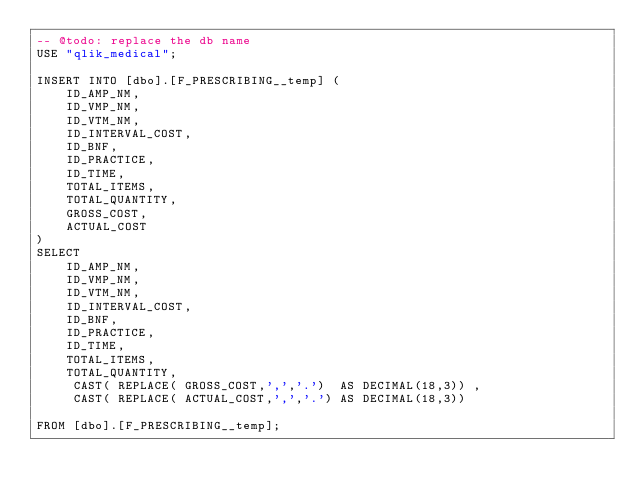<code> <loc_0><loc_0><loc_500><loc_500><_SQL_>-- @todo: replace the db name
USE "qlik_medical";

INSERT INTO [dbo].[F_PRESCRIBING__temp] (
	ID_AMP_NM,
	ID_VMP_NM,
	ID_VTM_NM,
	ID_INTERVAL_COST,
	ID_BNF,
	ID_PRACTICE,
	ID_TIME,
	TOTAL_ITEMS,
	TOTAL_QUANTITY,
	GROSS_COST,
	ACTUAL_COST
)
SELECT
	ID_AMP_NM,
	ID_VMP_NM,
	ID_VTM_NM,
	ID_INTERVAL_COST,
	ID_BNF,
	ID_PRACTICE,
	ID_TIME,
	TOTAL_ITEMS,
	TOTAL_QUANTITY,
	 CAST( REPLACE( GROSS_COST,',','.')  AS DECIMAL(18,3)) ,
	 CAST( REPLACE( ACTUAL_COST,',','.') AS DECIMAL(18,3))

FROM [dbo].[F_PRESCRIBING__temp];</code> 